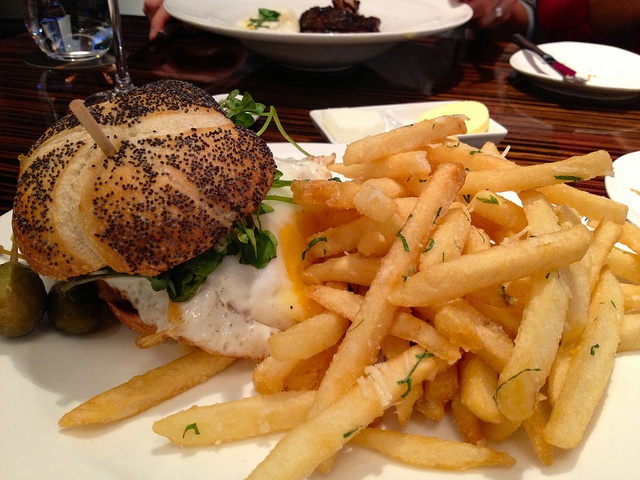Describe the objects in this image and their specific colors. I can see dining table in black, tan, red, and maroon tones, sandwich in black, maroon, brown, and gray tones, bowl in black, lightgray, and tan tones, wine glass in black, gray, navy, and darkgray tones, and knife in black, maroon, gray, and darkgray tones in this image. 